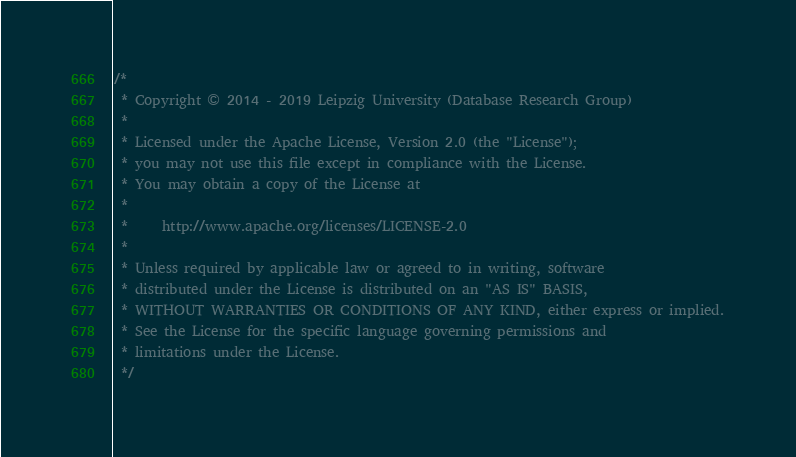Convert code to text. <code><loc_0><loc_0><loc_500><loc_500><_Java_>/*
 * Copyright © 2014 - 2019 Leipzig University (Database Research Group)
 *
 * Licensed under the Apache License, Version 2.0 (the "License");
 * you may not use this file except in compliance with the License.
 * You may obtain a copy of the License at
 *
 *     http://www.apache.org/licenses/LICENSE-2.0
 *
 * Unless required by applicable law or agreed to in writing, software
 * distributed under the License is distributed on an "AS IS" BASIS,
 * WITHOUT WARRANTIES OR CONDITIONS OF ANY KIND, either express or implied.
 * See the License for the specific language governing permissions and
 * limitations under the License.
 */</code> 